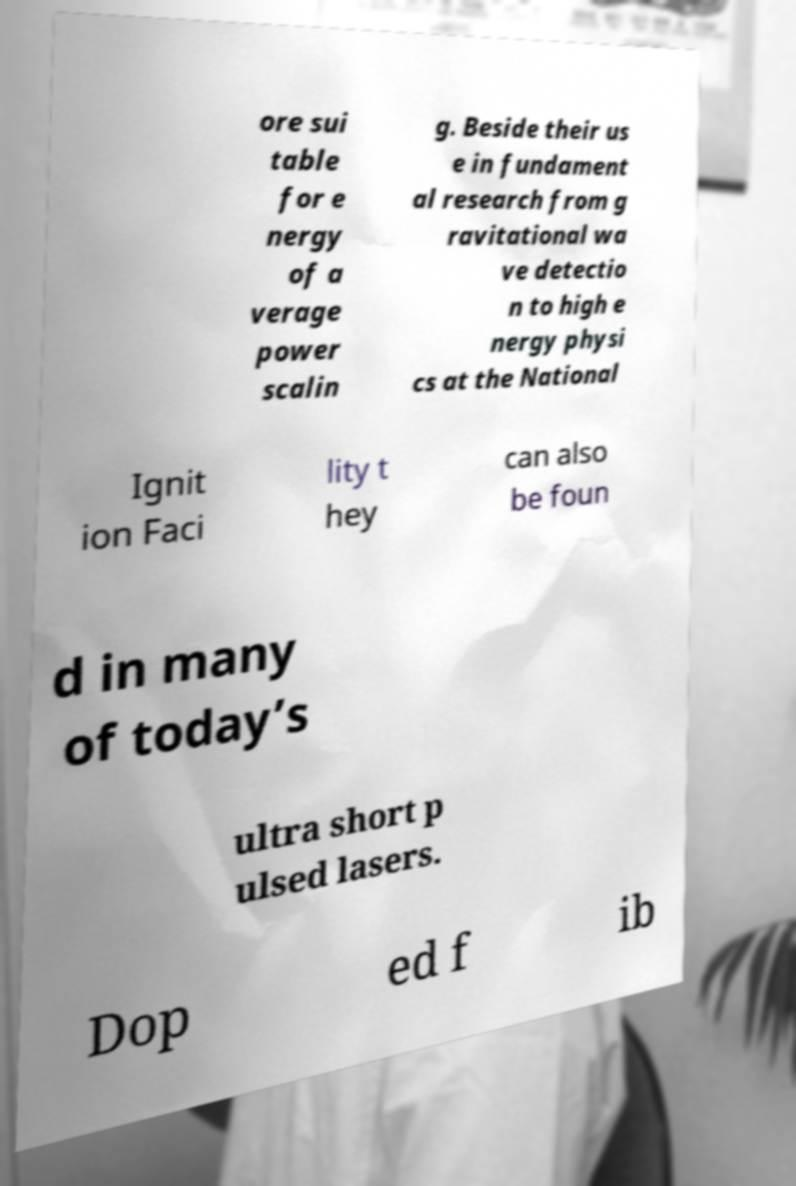I need the written content from this picture converted into text. Can you do that? ore sui table for e nergy of a verage power scalin g. Beside their us e in fundament al research from g ravitational wa ve detectio n to high e nergy physi cs at the National Ignit ion Faci lity t hey can also be foun d in many of today’s ultra short p ulsed lasers. Dop ed f ib 